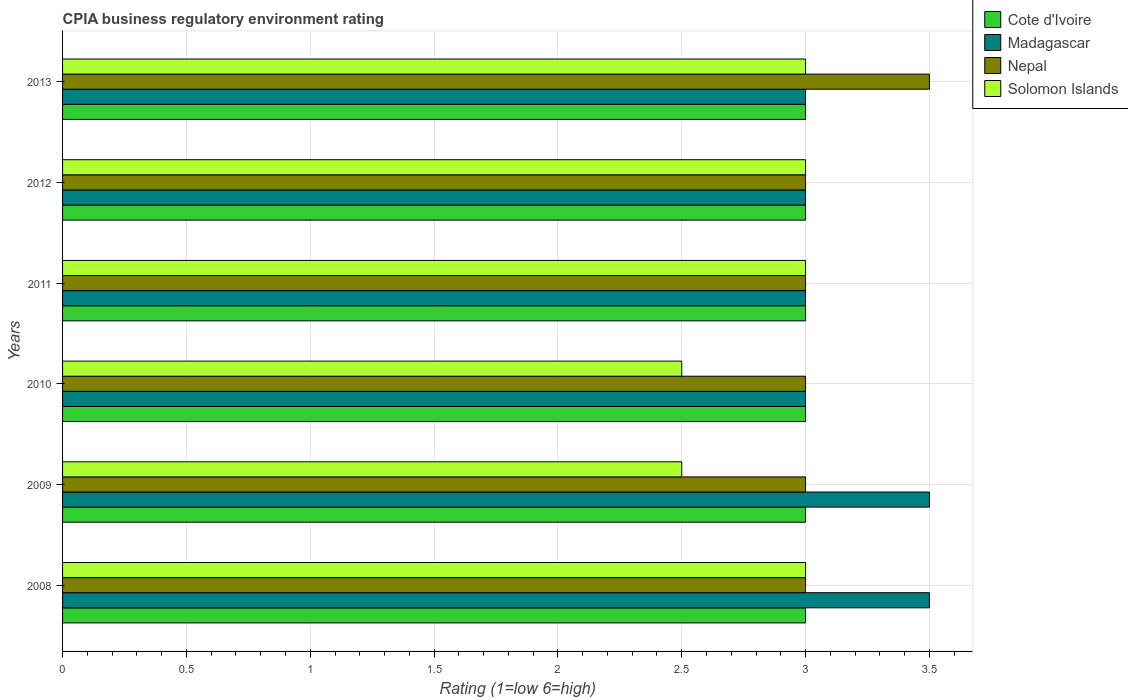How many groups of bars are there?
Your response must be concise. 6. Are the number of bars per tick equal to the number of legend labels?
Provide a succinct answer. Yes. How many bars are there on the 1st tick from the top?
Provide a succinct answer. 4. In how many cases, is the number of bars for a given year not equal to the number of legend labels?
Offer a terse response. 0. Across all years, what is the minimum CPIA rating in Cote d'Ivoire?
Provide a short and direct response. 3. In which year was the CPIA rating in Cote d'Ivoire minimum?
Offer a terse response. 2008. What is the total CPIA rating in Solomon Islands in the graph?
Provide a succinct answer. 17. What is the difference between the CPIA rating in Cote d'Ivoire in 2008 and the CPIA rating in Madagascar in 2012?
Offer a terse response. 0. What is the average CPIA rating in Nepal per year?
Your answer should be very brief. 3.08. Is the difference between the CPIA rating in Solomon Islands in 2011 and 2012 greater than the difference between the CPIA rating in Madagascar in 2011 and 2012?
Provide a succinct answer. No. What is the difference between the highest and the lowest CPIA rating in Cote d'Ivoire?
Provide a short and direct response. 0. Is the sum of the CPIA rating in Nepal in 2008 and 2009 greater than the maximum CPIA rating in Madagascar across all years?
Ensure brevity in your answer.  Yes. What does the 3rd bar from the top in 2009 represents?
Offer a terse response. Madagascar. What does the 2nd bar from the bottom in 2013 represents?
Offer a very short reply. Madagascar. Is it the case that in every year, the sum of the CPIA rating in Solomon Islands and CPIA rating in Nepal is greater than the CPIA rating in Cote d'Ivoire?
Provide a short and direct response. Yes. How many bars are there?
Your answer should be very brief. 24. How many years are there in the graph?
Keep it short and to the point. 6. Does the graph contain any zero values?
Your response must be concise. No. How many legend labels are there?
Your response must be concise. 4. What is the title of the graph?
Give a very brief answer. CPIA business regulatory environment rating. What is the label or title of the X-axis?
Give a very brief answer. Rating (1=low 6=high). What is the Rating (1=low 6=high) of Cote d'Ivoire in 2008?
Your answer should be very brief. 3. What is the Rating (1=low 6=high) in Nepal in 2008?
Your response must be concise. 3. What is the Rating (1=low 6=high) in Madagascar in 2009?
Your answer should be very brief. 3.5. What is the Rating (1=low 6=high) of Nepal in 2009?
Offer a very short reply. 3. What is the Rating (1=low 6=high) of Solomon Islands in 2009?
Make the answer very short. 2.5. What is the Rating (1=low 6=high) of Madagascar in 2010?
Provide a succinct answer. 3. What is the Rating (1=low 6=high) of Solomon Islands in 2010?
Your answer should be very brief. 2.5. What is the Rating (1=low 6=high) in Cote d'Ivoire in 2011?
Offer a terse response. 3. What is the Rating (1=low 6=high) in Solomon Islands in 2011?
Give a very brief answer. 3. What is the Rating (1=low 6=high) in Madagascar in 2012?
Offer a terse response. 3. What is the Rating (1=low 6=high) of Madagascar in 2013?
Provide a succinct answer. 3. What is the Rating (1=low 6=high) of Nepal in 2013?
Offer a terse response. 3.5. Across all years, what is the maximum Rating (1=low 6=high) of Madagascar?
Ensure brevity in your answer.  3.5. Across all years, what is the minimum Rating (1=low 6=high) in Madagascar?
Offer a very short reply. 3. Across all years, what is the minimum Rating (1=low 6=high) in Nepal?
Offer a very short reply. 3. Across all years, what is the minimum Rating (1=low 6=high) in Solomon Islands?
Provide a succinct answer. 2.5. What is the total Rating (1=low 6=high) of Cote d'Ivoire in the graph?
Provide a succinct answer. 18. What is the total Rating (1=low 6=high) of Nepal in the graph?
Offer a very short reply. 18.5. What is the total Rating (1=low 6=high) of Solomon Islands in the graph?
Offer a terse response. 17. What is the difference between the Rating (1=low 6=high) in Cote d'Ivoire in 2008 and that in 2009?
Your answer should be very brief. 0. What is the difference between the Rating (1=low 6=high) in Solomon Islands in 2008 and that in 2009?
Provide a succinct answer. 0.5. What is the difference between the Rating (1=low 6=high) of Cote d'Ivoire in 2008 and that in 2010?
Your response must be concise. 0. What is the difference between the Rating (1=low 6=high) of Nepal in 2008 and that in 2010?
Provide a short and direct response. 0. What is the difference between the Rating (1=low 6=high) of Solomon Islands in 2008 and that in 2010?
Your answer should be compact. 0.5. What is the difference between the Rating (1=low 6=high) of Madagascar in 2008 and that in 2011?
Provide a succinct answer. 0.5. What is the difference between the Rating (1=low 6=high) in Madagascar in 2009 and that in 2010?
Offer a terse response. 0.5. What is the difference between the Rating (1=low 6=high) in Madagascar in 2009 and that in 2011?
Give a very brief answer. 0.5. What is the difference between the Rating (1=low 6=high) of Solomon Islands in 2009 and that in 2011?
Offer a very short reply. -0.5. What is the difference between the Rating (1=low 6=high) of Cote d'Ivoire in 2009 and that in 2012?
Ensure brevity in your answer.  0. What is the difference between the Rating (1=low 6=high) of Solomon Islands in 2009 and that in 2012?
Provide a short and direct response. -0.5. What is the difference between the Rating (1=low 6=high) of Cote d'Ivoire in 2009 and that in 2013?
Your answer should be compact. 0. What is the difference between the Rating (1=low 6=high) in Madagascar in 2009 and that in 2013?
Make the answer very short. 0.5. What is the difference between the Rating (1=low 6=high) of Nepal in 2009 and that in 2013?
Make the answer very short. -0.5. What is the difference between the Rating (1=low 6=high) in Cote d'Ivoire in 2010 and that in 2011?
Your response must be concise. 0. What is the difference between the Rating (1=low 6=high) of Solomon Islands in 2010 and that in 2011?
Ensure brevity in your answer.  -0.5. What is the difference between the Rating (1=low 6=high) of Cote d'Ivoire in 2010 and that in 2012?
Offer a terse response. 0. What is the difference between the Rating (1=low 6=high) in Nepal in 2010 and that in 2012?
Your response must be concise. 0. What is the difference between the Rating (1=low 6=high) of Solomon Islands in 2010 and that in 2012?
Provide a short and direct response. -0.5. What is the difference between the Rating (1=low 6=high) of Cote d'Ivoire in 2010 and that in 2013?
Keep it short and to the point. 0. What is the difference between the Rating (1=low 6=high) in Solomon Islands in 2010 and that in 2013?
Your response must be concise. -0.5. What is the difference between the Rating (1=low 6=high) of Solomon Islands in 2011 and that in 2012?
Your answer should be very brief. 0. What is the difference between the Rating (1=low 6=high) of Cote d'Ivoire in 2011 and that in 2013?
Ensure brevity in your answer.  0. What is the difference between the Rating (1=low 6=high) of Nepal in 2011 and that in 2013?
Make the answer very short. -0.5. What is the difference between the Rating (1=low 6=high) of Solomon Islands in 2011 and that in 2013?
Make the answer very short. 0. What is the difference between the Rating (1=low 6=high) of Cote d'Ivoire in 2012 and that in 2013?
Give a very brief answer. 0. What is the difference between the Rating (1=low 6=high) in Madagascar in 2012 and that in 2013?
Offer a terse response. 0. What is the difference between the Rating (1=low 6=high) of Nepal in 2012 and that in 2013?
Keep it short and to the point. -0.5. What is the difference between the Rating (1=low 6=high) in Cote d'Ivoire in 2008 and the Rating (1=low 6=high) in Madagascar in 2009?
Offer a terse response. -0.5. What is the difference between the Rating (1=low 6=high) of Madagascar in 2008 and the Rating (1=low 6=high) of Nepal in 2009?
Keep it short and to the point. 0.5. What is the difference between the Rating (1=low 6=high) of Madagascar in 2008 and the Rating (1=low 6=high) of Solomon Islands in 2009?
Keep it short and to the point. 1. What is the difference between the Rating (1=low 6=high) of Nepal in 2008 and the Rating (1=low 6=high) of Solomon Islands in 2009?
Provide a succinct answer. 0.5. What is the difference between the Rating (1=low 6=high) in Cote d'Ivoire in 2008 and the Rating (1=low 6=high) in Nepal in 2010?
Your answer should be compact. 0. What is the difference between the Rating (1=low 6=high) in Cote d'Ivoire in 2008 and the Rating (1=low 6=high) in Solomon Islands in 2010?
Your answer should be compact. 0.5. What is the difference between the Rating (1=low 6=high) in Madagascar in 2008 and the Rating (1=low 6=high) in Nepal in 2010?
Give a very brief answer. 0.5. What is the difference between the Rating (1=low 6=high) of Madagascar in 2008 and the Rating (1=low 6=high) of Solomon Islands in 2010?
Provide a short and direct response. 1. What is the difference between the Rating (1=low 6=high) of Cote d'Ivoire in 2008 and the Rating (1=low 6=high) of Madagascar in 2011?
Provide a short and direct response. 0. What is the difference between the Rating (1=low 6=high) of Madagascar in 2008 and the Rating (1=low 6=high) of Nepal in 2011?
Make the answer very short. 0.5. What is the difference between the Rating (1=low 6=high) of Madagascar in 2008 and the Rating (1=low 6=high) of Solomon Islands in 2011?
Provide a short and direct response. 0.5. What is the difference between the Rating (1=low 6=high) in Nepal in 2008 and the Rating (1=low 6=high) in Solomon Islands in 2011?
Provide a short and direct response. 0. What is the difference between the Rating (1=low 6=high) of Cote d'Ivoire in 2008 and the Rating (1=low 6=high) of Nepal in 2012?
Your response must be concise. 0. What is the difference between the Rating (1=low 6=high) in Cote d'Ivoire in 2008 and the Rating (1=low 6=high) in Solomon Islands in 2012?
Keep it short and to the point. 0. What is the difference between the Rating (1=low 6=high) in Madagascar in 2008 and the Rating (1=low 6=high) in Nepal in 2012?
Your answer should be compact. 0.5. What is the difference between the Rating (1=low 6=high) of Cote d'Ivoire in 2008 and the Rating (1=low 6=high) of Madagascar in 2013?
Offer a very short reply. 0. What is the difference between the Rating (1=low 6=high) in Cote d'Ivoire in 2008 and the Rating (1=low 6=high) in Solomon Islands in 2013?
Ensure brevity in your answer.  0. What is the difference between the Rating (1=low 6=high) in Madagascar in 2008 and the Rating (1=low 6=high) in Nepal in 2013?
Provide a succinct answer. 0. What is the difference between the Rating (1=low 6=high) of Madagascar in 2008 and the Rating (1=low 6=high) of Solomon Islands in 2013?
Make the answer very short. 0.5. What is the difference between the Rating (1=low 6=high) of Nepal in 2008 and the Rating (1=low 6=high) of Solomon Islands in 2013?
Provide a short and direct response. 0. What is the difference between the Rating (1=low 6=high) of Cote d'Ivoire in 2009 and the Rating (1=low 6=high) of Solomon Islands in 2010?
Keep it short and to the point. 0.5. What is the difference between the Rating (1=low 6=high) of Madagascar in 2009 and the Rating (1=low 6=high) of Nepal in 2010?
Make the answer very short. 0.5. What is the difference between the Rating (1=low 6=high) of Nepal in 2009 and the Rating (1=low 6=high) of Solomon Islands in 2010?
Make the answer very short. 0.5. What is the difference between the Rating (1=low 6=high) of Cote d'Ivoire in 2009 and the Rating (1=low 6=high) of Madagascar in 2011?
Offer a very short reply. 0. What is the difference between the Rating (1=low 6=high) in Nepal in 2009 and the Rating (1=low 6=high) in Solomon Islands in 2011?
Ensure brevity in your answer.  0. What is the difference between the Rating (1=low 6=high) of Cote d'Ivoire in 2009 and the Rating (1=low 6=high) of Madagascar in 2012?
Keep it short and to the point. 0. What is the difference between the Rating (1=low 6=high) of Cote d'Ivoire in 2009 and the Rating (1=low 6=high) of Nepal in 2013?
Make the answer very short. -0.5. What is the difference between the Rating (1=low 6=high) of Madagascar in 2009 and the Rating (1=low 6=high) of Nepal in 2013?
Keep it short and to the point. 0. What is the difference between the Rating (1=low 6=high) in Madagascar in 2009 and the Rating (1=low 6=high) in Solomon Islands in 2013?
Offer a terse response. 0.5. What is the difference between the Rating (1=low 6=high) in Cote d'Ivoire in 2010 and the Rating (1=low 6=high) in Madagascar in 2011?
Offer a terse response. 0. What is the difference between the Rating (1=low 6=high) in Madagascar in 2010 and the Rating (1=low 6=high) in Nepal in 2011?
Provide a short and direct response. 0. What is the difference between the Rating (1=low 6=high) of Madagascar in 2010 and the Rating (1=low 6=high) of Solomon Islands in 2011?
Provide a succinct answer. 0. What is the difference between the Rating (1=low 6=high) of Nepal in 2010 and the Rating (1=low 6=high) of Solomon Islands in 2011?
Make the answer very short. 0. What is the difference between the Rating (1=low 6=high) of Cote d'Ivoire in 2010 and the Rating (1=low 6=high) of Solomon Islands in 2012?
Offer a very short reply. 0. What is the difference between the Rating (1=low 6=high) in Madagascar in 2010 and the Rating (1=low 6=high) in Nepal in 2012?
Offer a terse response. 0. What is the difference between the Rating (1=low 6=high) of Madagascar in 2010 and the Rating (1=low 6=high) of Solomon Islands in 2012?
Keep it short and to the point. 0. What is the difference between the Rating (1=low 6=high) of Nepal in 2010 and the Rating (1=low 6=high) of Solomon Islands in 2012?
Ensure brevity in your answer.  0. What is the difference between the Rating (1=low 6=high) of Cote d'Ivoire in 2010 and the Rating (1=low 6=high) of Solomon Islands in 2013?
Keep it short and to the point. 0. What is the difference between the Rating (1=low 6=high) in Nepal in 2010 and the Rating (1=low 6=high) in Solomon Islands in 2013?
Your response must be concise. 0. What is the difference between the Rating (1=low 6=high) in Cote d'Ivoire in 2011 and the Rating (1=low 6=high) in Madagascar in 2012?
Offer a terse response. 0. What is the difference between the Rating (1=low 6=high) in Madagascar in 2011 and the Rating (1=low 6=high) in Nepal in 2012?
Make the answer very short. 0. What is the difference between the Rating (1=low 6=high) in Madagascar in 2011 and the Rating (1=low 6=high) in Solomon Islands in 2012?
Give a very brief answer. 0. What is the difference between the Rating (1=low 6=high) in Cote d'Ivoire in 2011 and the Rating (1=low 6=high) in Madagascar in 2013?
Give a very brief answer. 0. What is the difference between the Rating (1=low 6=high) in Cote d'Ivoire in 2011 and the Rating (1=low 6=high) in Nepal in 2013?
Make the answer very short. -0.5. What is the difference between the Rating (1=low 6=high) in Cote d'Ivoire in 2012 and the Rating (1=low 6=high) in Madagascar in 2013?
Make the answer very short. 0. What is the difference between the Rating (1=low 6=high) of Cote d'Ivoire in 2012 and the Rating (1=low 6=high) of Nepal in 2013?
Offer a very short reply. -0.5. What is the difference between the Rating (1=low 6=high) of Cote d'Ivoire in 2012 and the Rating (1=low 6=high) of Solomon Islands in 2013?
Offer a very short reply. 0. What is the difference between the Rating (1=low 6=high) of Madagascar in 2012 and the Rating (1=low 6=high) of Nepal in 2013?
Your answer should be very brief. -0.5. What is the difference between the Rating (1=low 6=high) in Madagascar in 2012 and the Rating (1=low 6=high) in Solomon Islands in 2013?
Offer a very short reply. 0. What is the difference between the Rating (1=low 6=high) of Nepal in 2012 and the Rating (1=low 6=high) of Solomon Islands in 2013?
Your response must be concise. 0. What is the average Rating (1=low 6=high) in Madagascar per year?
Make the answer very short. 3.17. What is the average Rating (1=low 6=high) in Nepal per year?
Provide a succinct answer. 3.08. What is the average Rating (1=low 6=high) of Solomon Islands per year?
Give a very brief answer. 2.83. In the year 2008, what is the difference between the Rating (1=low 6=high) in Cote d'Ivoire and Rating (1=low 6=high) in Solomon Islands?
Provide a succinct answer. 0. In the year 2008, what is the difference between the Rating (1=low 6=high) of Madagascar and Rating (1=low 6=high) of Nepal?
Make the answer very short. 0.5. In the year 2008, what is the difference between the Rating (1=low 6=high) of Madagascar and Rating (1=low 6=high) of Solomon Islands?
Offer a very short reply. 0.5. In the year 2008, what is the difference between the Rating (1=low 6=high) of Nepal and Rating (1=low 6=high) of Solomon Islands?
Keep it short and to the point. 0. In the year 2009, what is the difference between the Rating (1=low 6=high) in Madagascar and Rating (1=low 6=high) in Nepal?
Give a very brief answer. 0.5. In the year 2010, what is the difference between the Rating (1=low 6=high) of Cote d'Ivoire and Rating (1=low 6=high) of Nepal?
Your answer should be very brief. 0. In the year 2010, what is the difference between the Rating (1=low 6=high) in Madagascar and Rating (1=low 6=high) in Nepal?
Your answer should be very brief. 0. In the year 2010, what is the difference between the Rating (1=low 6=high) in Nepal and Rating (1=low 6=high) in Solomon Islands?
Your answer should be very brief. 0.5. In the year 2011, what is the difference between the Rating (1=low 6=high) in Cote d'Ivoire and Rating (1=low 6=high) in Nepal?
Offer a terse response. 0. In the year 2011, what is the difference between the Rating (1=low 6=high) of Cote d'Ivoire and Rating (1=low 6=high) of Solomon Islands?
Provide a succinct answer. 0. In the year 2011, what is the difference between the Rating (1=low 6=high) of Madagascar and Rating (1=low 6=high) of Nepal?
Ensure brevity in your answer.  0. In the year 2012, what is the difference between the Rating (1=low 6=high) of Cote d'Ivoire and Rating (1=low 6=high) of Madagascar?
Your response must be concise. 0. In the year 2012, what is the difference between the Rating (1=low 6=high) in Cote d'Ivoire and Rating (1=low 6=high) in Nepal?
Your response must be concise. 0. In the year 2012, what is the difference between the Rating (1=low 6=high) of Cote d'Ivoire and Rating (1=low 6=high) of Solomon Islands?
Provide a short and direct response. 0. In the year 2012, what is the difference between the Rating (1=low 6=high) in Madagascar and Rating (1=low 6=high) in Nepal?
Your response must be concise. 0. In the year 2012, what is the difference between the Rating (1=low 6=high) of Madagascar and Rating (1=low 6=high) of Solomon Islands?
Provide a succinct answer. 0. In the year 2013, what is the difference between the Rating (1=low 6=high) of Cote d'Ivoire and Rating (1=low 6=high) of Solomon Islands?
Make the answer very short. 0. In the year 2013, what is the difference between the Rating (1=low 6=high) in Madagascar and Rating (1=low 6=high) in Nepal?
Keep it short and to the point. -0.5. In the year 2013, what is the difference between the Rating (1=low 6=high) in Nepal and Rating (1=low 6=high) in Solomon Islands?
Give a very brief answer. 0.5. What is the ratio of the Rating (1=low 6=high) in Cote d'Ivoire in 2008 to that in 2009?
Offer a very short reply. 1. What is the ratio of the Rating (1=low 6=high) in Nepal in 2008 to that in 2009?
Give a very brief answer. 1. What is the ratio of the Rating (1=low 6=high) of Solomon Islands in 2008 to that in 2009?
Provide a short and direct response. 1.2. What is the ratio of the Rating (1=low 6=high) of Nepal in 2008 to that in 2010?
Provide a short and direct response. 1. What is the ratio of the Rating (1=low 6=high) of Cote d'Ivoire in 2008 to that in 2011?
Make the answer very short. 1. What is the ratio of the Rating (1=low 6=high) of Madagascar in 2008 to that in 2011?
Offer a very short reply. 1.17. What is the ratio of the Rating (1=low 6=high) in Cote d'Ivoire in 2008 to that in 2012?
Your response must be concise. 1. What is the ratio of the Rating (1=low 6=high) in Madagascar in 2008 to that in 2012?
Offer a terse response. 1.17. What is the ratio of the Rating (1=low 6=high) of Nepal in 2008 to that in 2012?
Offer a very short reply. 1. What is the ratio of the Rating (1=low 6=high) of Madagascar in 2008 to that in 2013?
Ensure brevity in your answer.  1.17. What is the ratio of the Rating (1=low 6=high) of Nepal in 2008 to that in 2013?
Ensure brevity in your answer.  0.86. What is the ratio of the Rating (1=low 6=high) in Solomon Islands in 2008 to that in 2013?
Offer a very short reply. 1. What is the ratio of the Rating (1=low 6=high) in Madagascar in 2009 to that in 2010?
Keep it short and to the point. 1.17. What is the ratio of the Rating (1=low 6=high) of Cote d'Ivoire in 2009 to that in 2011?
Ensure brevity in your answer.  1. What is the ratio of the Rating (1=low 6=high) in Madagascar in 2009 to that in 2011?
Keep it short and to the point. 1.17. What is the ratio of the Rating (1=low 6=high) in Nepal in 2009 to that in 2011?
Provide a short and direct response. 1. What is the ratio of the Rating (1=low 6=high) in Solomon Islands in 2009 to that in 2011?
Provide a short and direct response. 0.83. What is the ratio of the Rating (1=low 6=high) of Cote d'Ivoire in 2009 to that in 2012?
Your response must be concise. 1. What is the ratio of the Rating (1=low 6=high) in Nepal in 2009 to that in 2012?
Your answer should be compact. 1. What is the ratio of the Rating (1=low 6=high) in Solomon Islands in 2009 to that in 2012?
Give a very brief answer. 0.83. What is the ratio of the Rating (1=low 6=high) of Nepal in 2009 to that in 2013?
Offer a terse response. 0.86. What is the ratio of the Rating (1=low 6=high) of Solomon Islands in 2009 to that in 2013?
Your answer should be compact. 0.83. What is the ratio of the Rating (1=low 6=high) in Nepal in 2010 to that in 2011?
Offer a terse response. 1. What is the ratio of the Rating (1=low 6=high) in Cote d'Ivoire in 2010 to that in 2012?
Your response must be concise. 1. What is the ratio of the Rating (1=low 6=high) in Nepal in 2010 to that in 2012?
Keep it short and to the point. 1. What is the ratio of the Rating (1=low 6=high) of Nepal in 2010 to that in 2013?
Make the answer very short. 0.86. What is the ratio of the Rating (1=low 6=high) of Solomon Islands in 2010 to that in 2013?
Offer a terse response. 0.83. What is the ratio of the Rating (1=low 6=high) in Madagascar in 2011 to that in 2012?
Provide a succinct answer. 1. What is the ratio of the Rating (1=low 6=high) of Solomon Islands in 2011 to that in 2012?
Your response must be concise. 1. What is the ratio of the Rating (1=low 6=high) in Cote d'Ivoire in 2011 to that in 2013?
Ensure brevity in your answer.  1. What is the ratio of the Rating (1=low 6=high) in Nepal in 2011 to that in 2013?
Your answer should be very brief. 0.86. What is the ratio of the Rating (1=low 6=high) of Cote d'Ivoire in 2012 to that in 2013?
Provide a short and direct response. 1. What is the ratio of the Rating (1=low 6=high) in Nepal in 2012 to that in 2013?
Offer a terse response. 0.86. What is the difference between the highest and the second highest Rating (1=low 6=high) in Nepal?
Offer a terse response. 0.5. What is the difference between the highest and the second highest Rating (1=low 6=high) in Solomon Islands?
Give a very brief answer. 0. What is the difference between the highest and the lowest Rating (1=low 6=high) in Cote d'Ivoire?
Ensure brevity in your answer.  0. What is the difference between the highest and the lowest Rating (1=low 6=high) of Madagascar?
Give a very brief answer. 0.5. What is the difference between the highest and the lowest Rating (1=low 6=high) in Nepal?
Ensure brevity in your answer.  0.5. What is the difference between the highest and the lowest Rating (1=low 6=high) in Solomon Islands?
Your answer should be very brief. 0.5. 